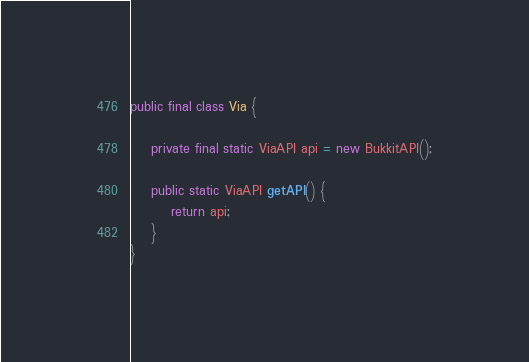<code> <loc_0><loc_0><loc_500><loc_500><_Java_>public final class Via {

    private final static ViaAPI api = new BukkitAPI();

    public static ViaAPI getAPI() {
        return api;
    }
}
</code> 